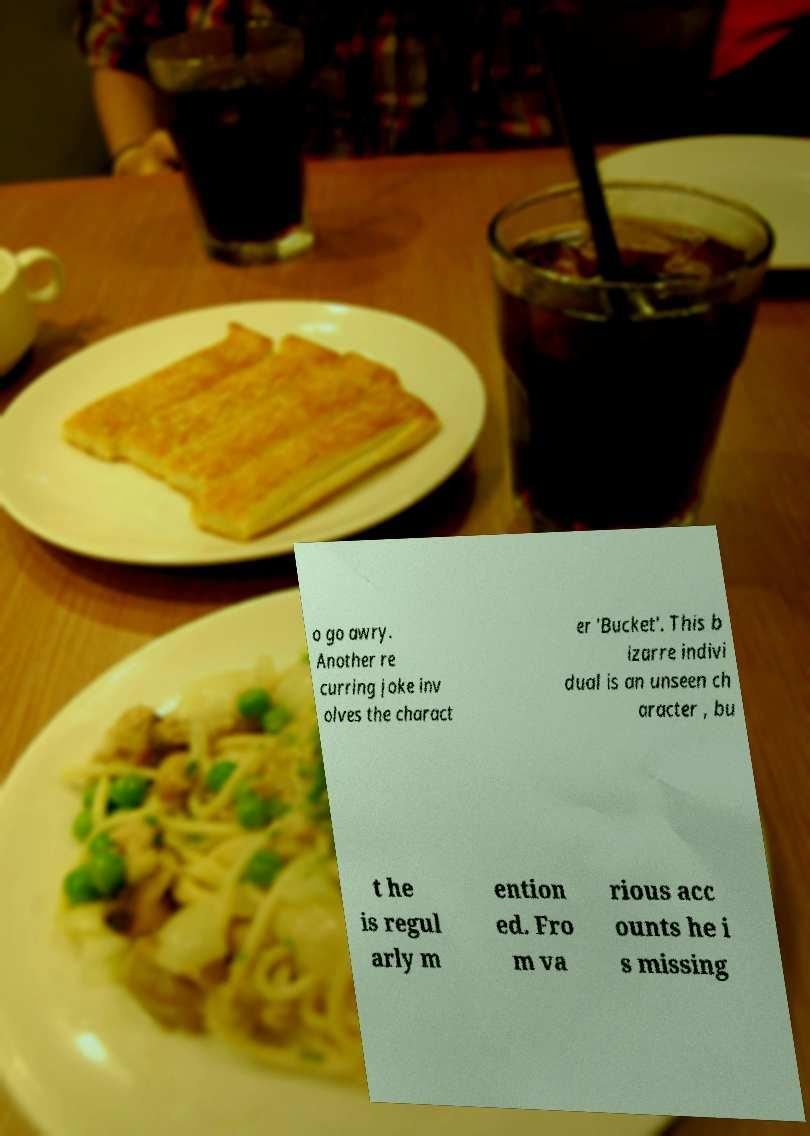For documentation purposes, I need the text within this image transcribed. Could you provide that? o go awry. Another re curring joke inv olves the charact er 'Bucket'. This b izarre indivi dual is an unseen ch aracter , bu t he is regul arly m ention ed. Fro m va rious acc ounts he i s missing 